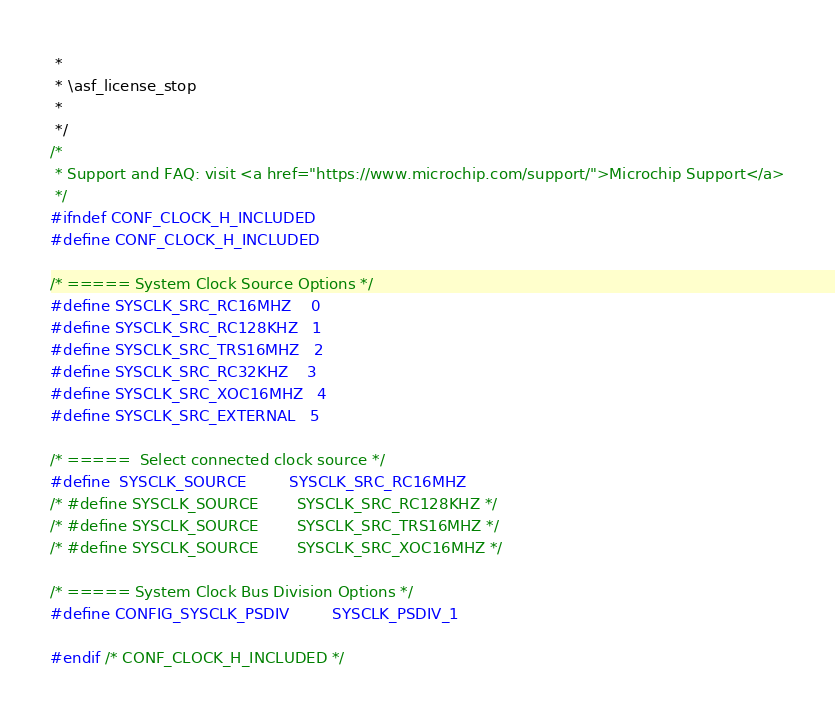<code> <loc_0><loc_0><loc_500><loc_500><_C_> *
 * \asf_license_stop
 *
 */
/*
 * Support and FAQ: visit <a href="https://www.microchip.com/support/">Microchip Support</a>
 */
#ifndef CONF_CLOCK_H_INCLUDED
#define CONF_CLOCK_H_INCLUDED

/* ===== System Clock Source Options */
#define SYSCLK_SRC_RC16MHZ    0
#define SYSCLK_SRC_RC128KHZ   1
#define SYSCLK_SRC_TRS16MHZ   2
#define SYSCLK_SRC_RC32KHZ    3
#define SYSCLK_SRC_XOC16MHZ   4
#define SYSCLK_SRC_EXTERNAL   5

/* =====  Select connected clock source */
#define  SYSCLK_SOURCE         SYSCLK_SRC_RC16MHZ
/* #define SYSCLK_SOURCE        SYSCLK_SRC_RC128KHZ */
/* #define SYSCLK_SOURCE        SYSCLK_SRC_TRS16MHZ */
/* #define SYSCLK_SOURCE        SYSCLK_SRC_XOC16MHZ */

/* ===== System Clock Bus Division Options */
#define CONFIG_SYSCLK_PSDIV         SYSCLK_PSDIV_1

#endif /* CONF_CLOCK_H_INCLUDED */
</code> 